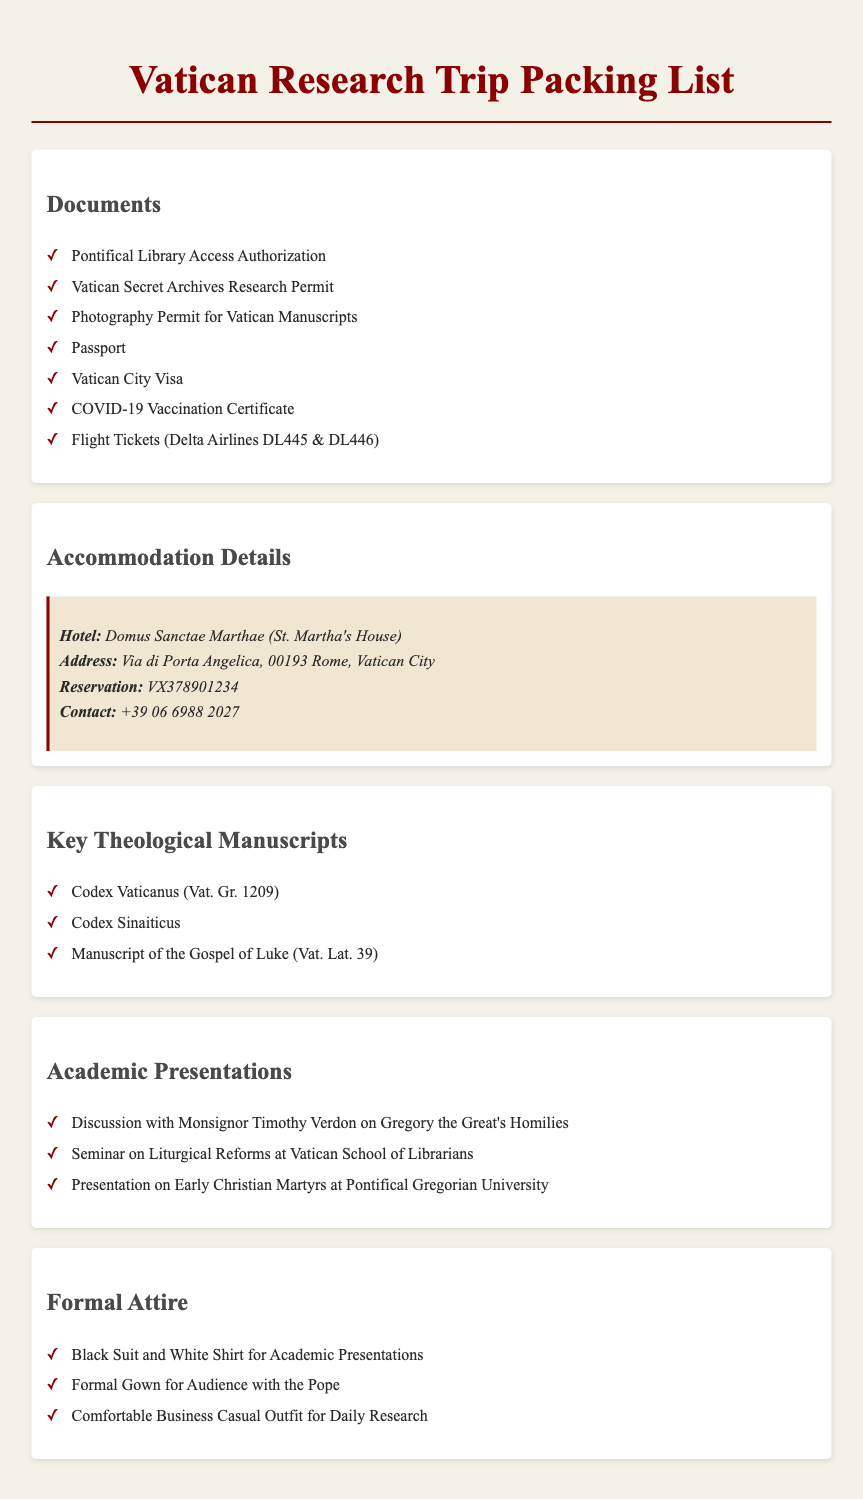What is the hotel name? The hotel name is mentioned in the Accommodation Details section of the document.
Answer: Domus Sanctae Marthae How many research permits are listed? The document lists several research permits in the Documents section.
Answer: 3 What is the address of the accommodation? The document provides specific accommodation details, including the address.
Answer: Via di Porta Angelica, 00193 Rome, Vatican City Who is the discussion with regarding Gregory the Great's Homilies? The person's name is mentioned in the Academic Presentations section of the document.
Answer: Monsignor Timothy Verdon What type of gown is required for the audience with the Pope? The document specifies the formal attire needed for the audience.
Answer: Formal Gown Which manuscript is noted as Codex Vaticanus? The document lists key theological manuscripts, one of which includes this specific title.
Answer: Codex Vaticanus (Vat. Gr. 1209) What is the contact number for the hotel? The contact number is provided in the Accommodation Details section.
Answer: +39 06 6988 2027 What are the flight numbers for Delta Airlines? The document specifically mentions the flight details in the Documents section.
Answer: DL445 & DL446 How many key theological manuscripts are listed? This is determined by counting the items in the Key Theological Manuscripts section of the document.
Answer: 3 